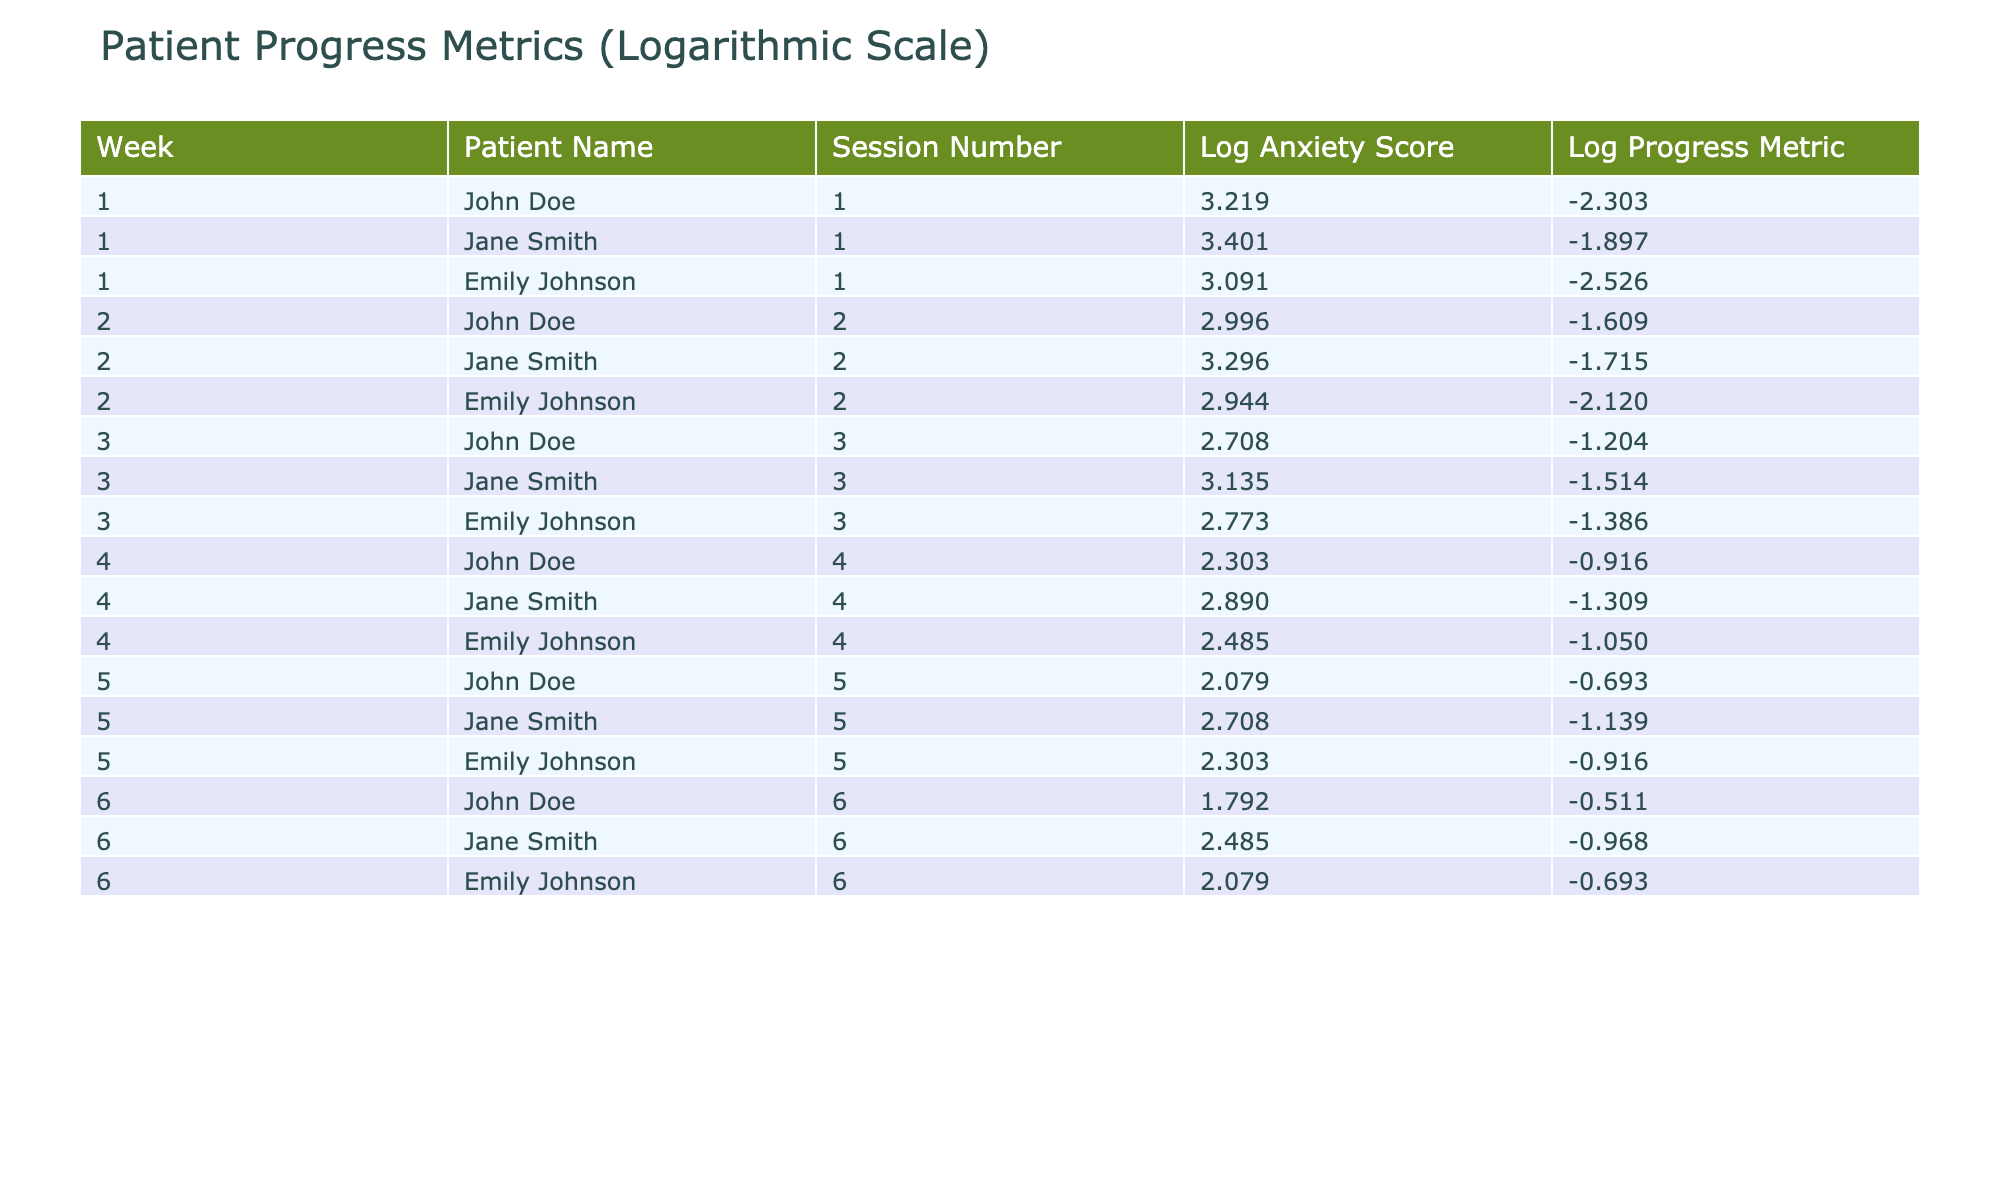What is the logarithmic Anxiety Score for Emily Johnson in Week 3? In Week 3, Emily Johnson's Anxiety Score is 16. Taking the logarithm gives Log_Anxiety_Score = log(16) ≈ 2.773.
Answer: 2.773 What was the maximum logarithmic Progress Metric across all patients and weeks? The Log_Progress_Metric values are: John Doe (0.000, 0.693, 1.099, 1.386, 1.609, 1.792), Jane Smith (0.405, 0.555, 0.336, 0.278, 0.654, 0.329), Emily Johnson (0.000, 0.182, 0.125, 0.301, 0.386, 0.693). The maximum value among these is 1.792.
Answer: 1.792 Did any patient show a logarithmic Anxiety Score of less than 2 during Week 1? In Week 1, the Log_Anxiety_Scores for John Doe (3.219), Jane Smith (3.401), and Emily Johnson (3.090) are all greater than 2. Therefore, none of the patients showed a score of less than 2.
Answer: No What is the average logarithmic Progress Metric for John Doe across all sessions? For John Doe: Log_Progress_Metric values are 0.000, 0.693, 1.099, 1.386, 1.609, 1.792. Their sum is 5.579, and dividing by 6 gives an average of approximately 0.930.
Answer: 0.930 In which week did Jane Smith show the highest progress in the logarithmic Progress Metric? Reviewing the Log_Progress_Metrics for Jane Smith: Week 1 (0.405), Week 2 (0.555), Week 3 (0.336), Week 4 (0.278), Week 5 (0.654), Week 6 (0.329). The highest value was 0.654 in Week 5.
Answer: Week 5 How many patients had a logarithmic Anxiety Score greater than 2 during Week 4? In Week 4, the Anxiety Scores were 10 for John Doe, 18 for Jane Smith, and 12 for Emily Johnson. Their logarithmic values are approximately 2.303 for John Doe, 2.890 for Jane Smith, and 2.485 for Emily Johnson. Only Jane Smith's score is greater than 2.
Answer: 1 